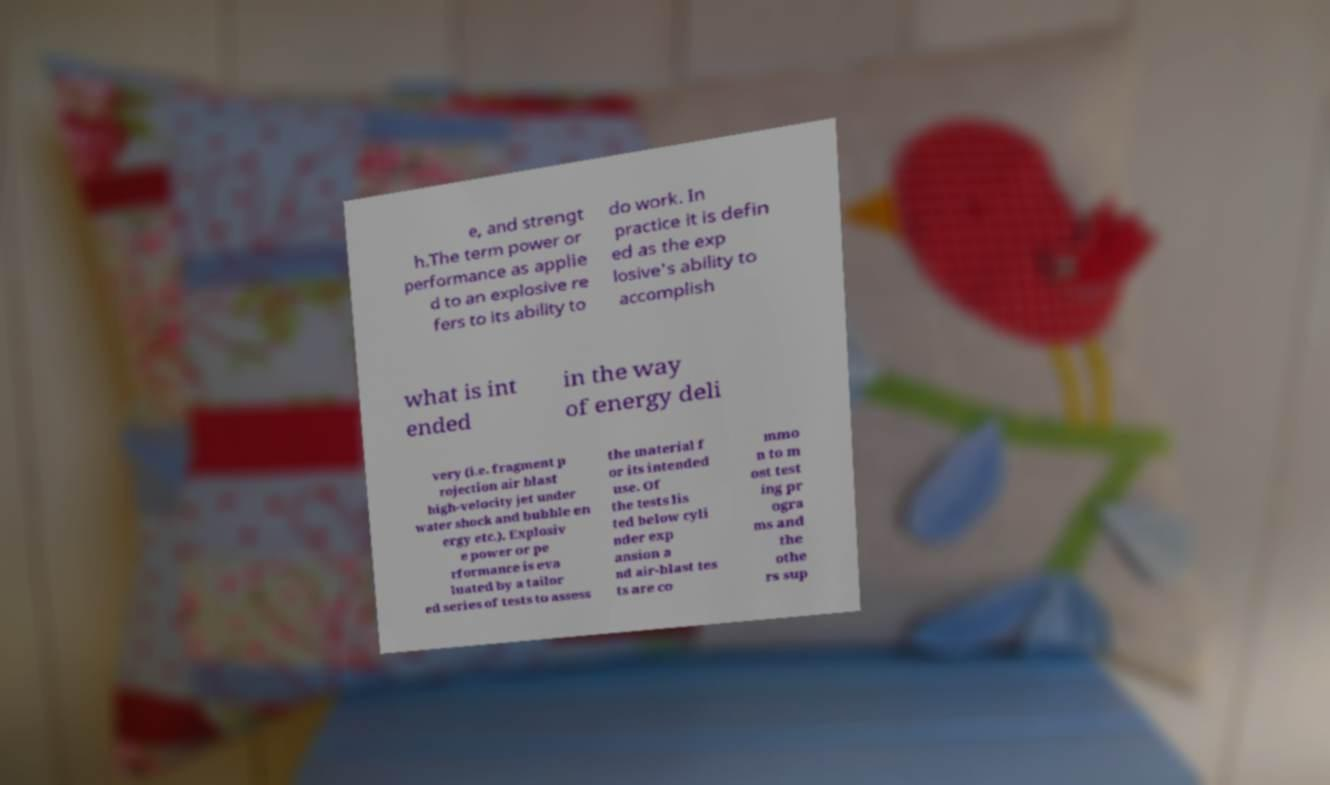For documentation purposes, I need the text within this image transcribed. Could you provide that? e, and strengt h.The term power or performance as applie d to an explosive re fers to its ability to do work. In practice it is defin ed as the exp losive's ability to accomplish what is int ended in the way of energy deli very (i.e. fragment p rojection air blast high-velocity jet under water shock and bubble en ergy etc.). Explosiv e power or pe rformance is eva luated by a tailor ed series of tests to assess the material f or its intended use. Of the tests lis ted below cyli nder exp ansion a nd air-blast tes ts are co mmo n to m ost test ing pr ogra ms and the othe rs sup 